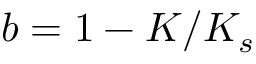<formula> <loc_0><loc_0><loc_500><loc_500>b = 1 - K / K _ { s }</formula> 